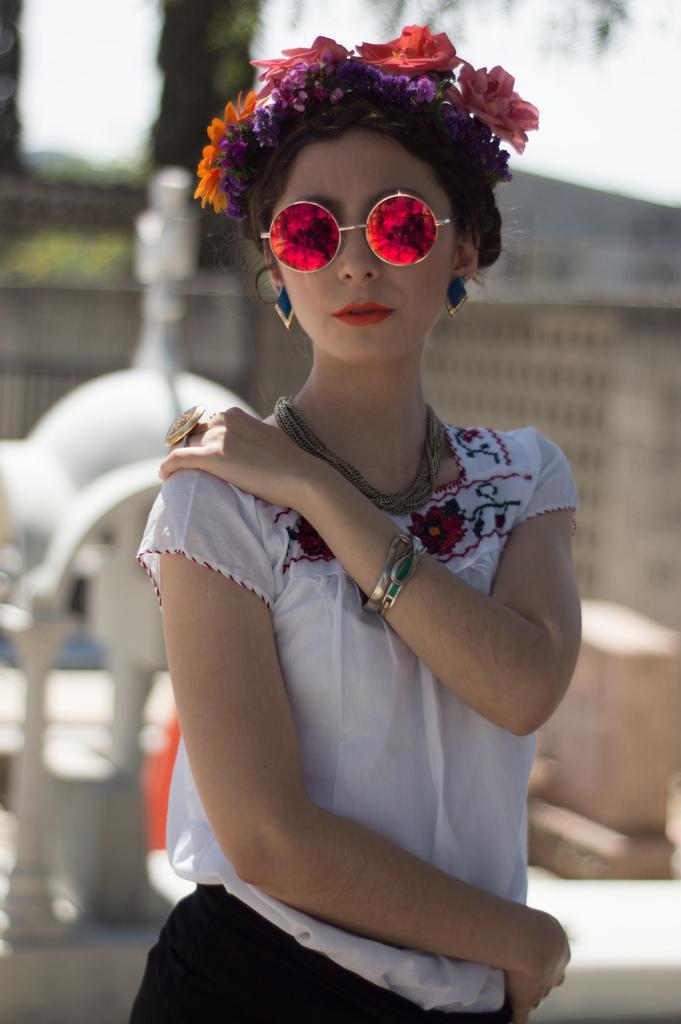Could you give a brief overview of what you see in this image? In this picture there is a Chinese girl wearing white top and a flower band on the head, standing and giving a pose into the camera. Behind there is a blur background. 